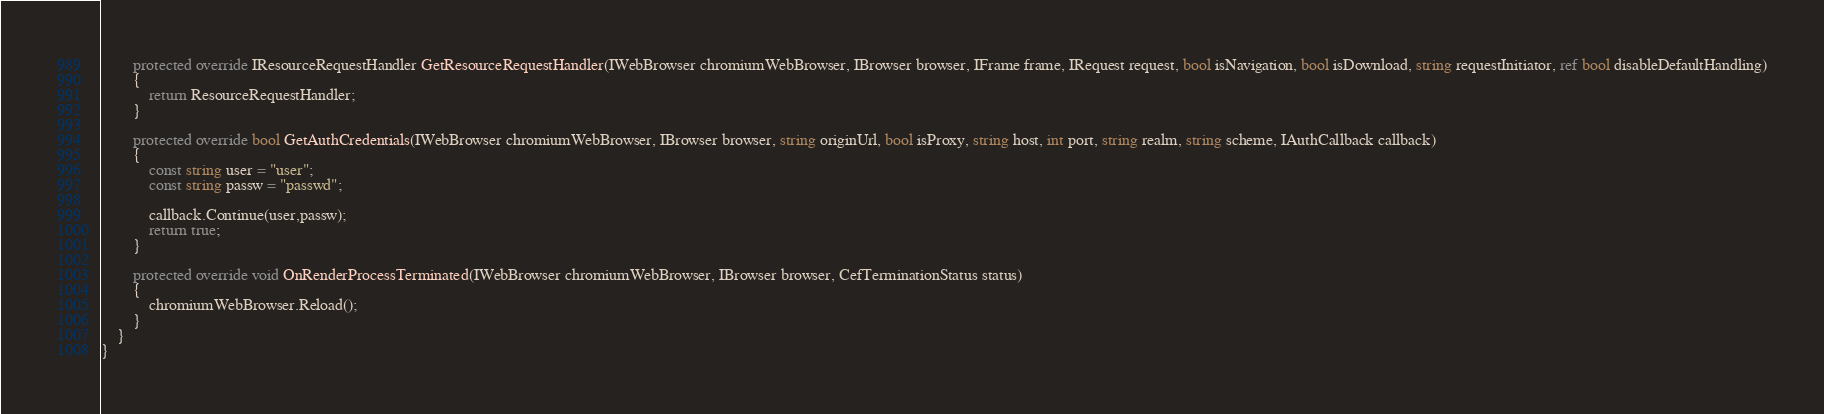Convert code to text. <code><loc_0><loc_0><loc_500><loc_500><_C#_>
        protected override IResourceRequestHandler GetResourceRequestHandler(IWebBrowser chromiumWebBrowser, IBrowser browser, IFrame frame, IRequest request, bool isNavigation, bool isDownload, string requestInitiator, ref bool disableDefaultHandling)
        {
            return ResourceRequestHandler;
        }

        protected override bool GetAuthCredentials(IWebBrowser chromiumWebBrowser, IBrowser browser, string originUrl, bool isProxy, string host, int port, string realm, string scheme, IAuthCallback callback)
        {
            const string user = "user";
            const string passw = "passwd";
            
            callback.Continue(user,passw);
            return true;
        }

        protected override void OnRenderProcessTerminated(IWebBrowser chromiumWebBrowser, IBrowser browser, CefTerminationStatus status)
        {
            chromiumWebBrowser.Reload();
        }
    }
}</code> 